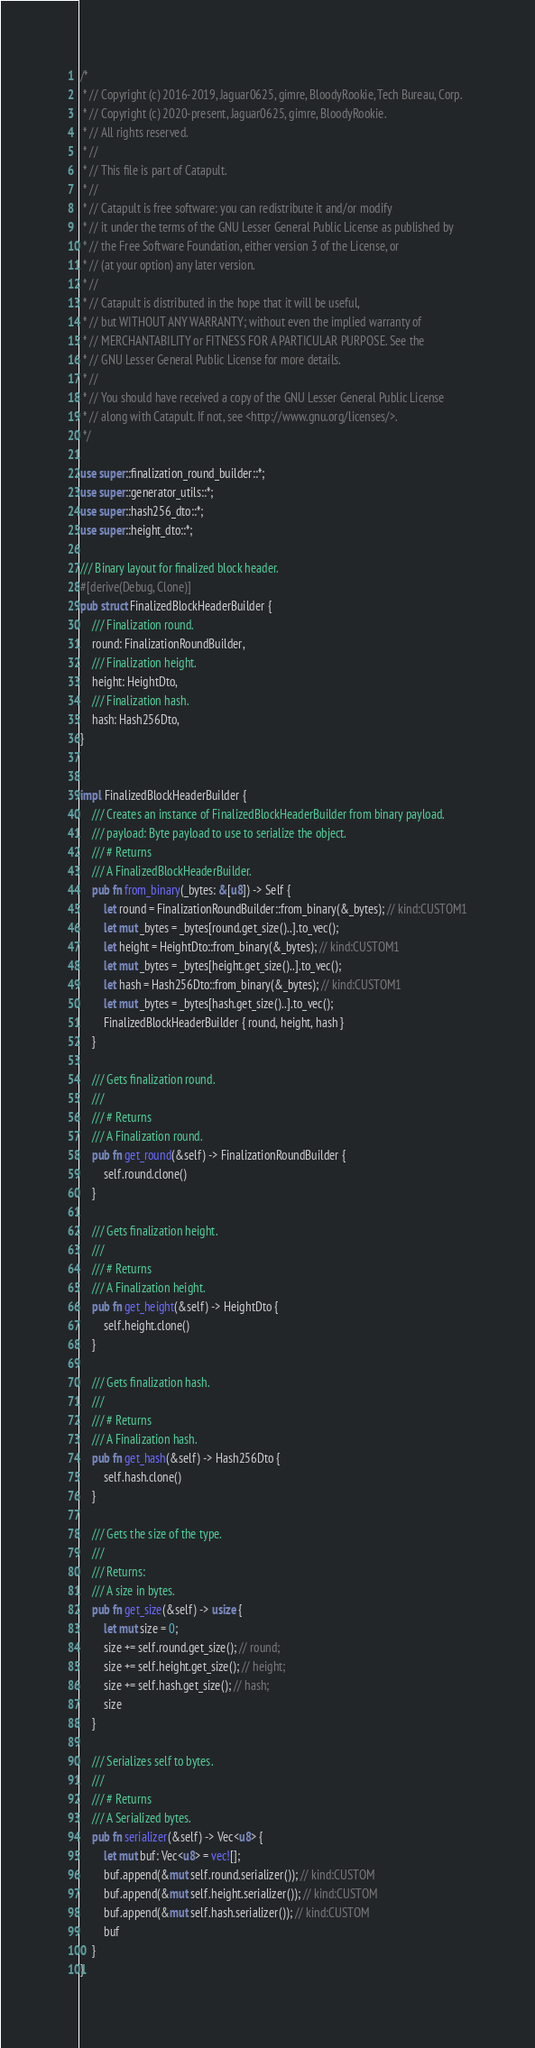Convert code to text. <code><loc_0><loc_0><loc_500><loc_500><_Rust_>/*
 * // Copyright (c) 2016-2019, Jaguar0625, gimre, BloodyRookie, Tech Bureau, Corp.
 * // Copyright (c) 2020-present, Jaguar0625, gimre, BloodyRookie.
 * // All rights reserved.
 * //
 * // This file is part of Catapult.
 * //
 * // Catapult is free software: you can redistribute it and/or modify
 * // it under the terms of the GNU Lesser General Public License as published by
 * // the Free Software Foundation, either version 3 of the License, or
 * // (at your option) any later version.
 * //
 * // Catapult is distributed in the hope that it will be useful,
 * // but WITHOUT ANY WARRANTY; without even the implied warranty of
 * // MERCHANTABILITY or FITNESS FOR A PARTICULAR PURPOSE. See the
 * // GNU Lesser General Public License for more details.
 * //
 * // You should have received a copy of the GNU Lesser General Public License
 * // along with Catapult. If not, see <http://www.gnu.org/licenses/>.
 */

use super::finalization_round_builder::*;
use super::generator_utils::*;
use super::hash256_dto::*;
use super::height_dto::*;

/// Binary layout for finalized block header.
#[derive(Debug, Clone)]
pub struct FinalizedBlockHeaderBuilder {
    /// Finalization round.
    round: FinalizationRoundBuilder,
    /// Finalization height.
    height: HeightDto,
    /// Finalization hash.
    hash: Hash256Dto,
}


impl FinalizedBlockHeaderBuilder {
    /// Creates an instance of FinalizedBlockHeaderBuilder from binary payload.
    /// payload: Byte payload to use to serialize the object.
    /// # Returns
    /// A FinalizedBlockHeaderBuilder.
    pub fn from_binary(_bytes: &[u8]) -> Self {
        let round = FinalizationRoundBuilder::from_binary(&_bytes); // kind:CUSTOM1
        let mut _bytes = _bytes[round.get_size()..].to_vec();
        let height = HeightDto::from_binary(&_bytes); // kind:CUSTOM1
        let mut _bytes = _bytes[height.get_size()..].to_vec();
        let hash = Hash256Dto::from_binary(&_bytes); // kind:CUSTOM1
        let mut _bytes = _bytes[hash.get_size()..].to_vec();
        FinalizedBlockHeaderBuilder { round, height, hash }
    }

    /// Gets finalization round.
    ///
    /// # Returns
    /// A Finalization round.
    pub fn get_round(&self) -> FinalizationRoundBuilder {
        self.round.clone()
    }

    /// Gets finalization height.
    ///
    /// # Returns
    /// A Finalization height.
    pub fn get_height(&self) -> HeightDto {
        self.height.clone()
    }

    /// Gets finalization hash.
    ///
    /// # Returns
    /// A Finalization hash.
    pub fn get_hash(&self) -> Hash256Dto {
        self.hash.clone()
    }

    /// Gets the size of the type.
    ///
    /// Returns:
    /// A size in bytes.
    pub fn get_size(&self) -> usize {
        let mut size = 0;
        size += self.round.get_size(); // round;
        size += self.height.get_size(); // height;
        size += self.hash.get_size(); // hash;
        size
    }

    /// Serializes self to bytes.
    ///
    /// # Returns
    /// A Serialized bytes.
    pub fn serializer(&self) -> Vec<u8> {
        let mut buf: Vec<u8> = vec![];
        buf.append(&mut self.round.serializer()); // kind:CUSTOM
        buf.append(&mut self.height.serializer()); // kind:CUSTOM
        buf.append(&mut self.hash.serializer()); // kind:CUSTOM
        buf
    }
}

</code> 